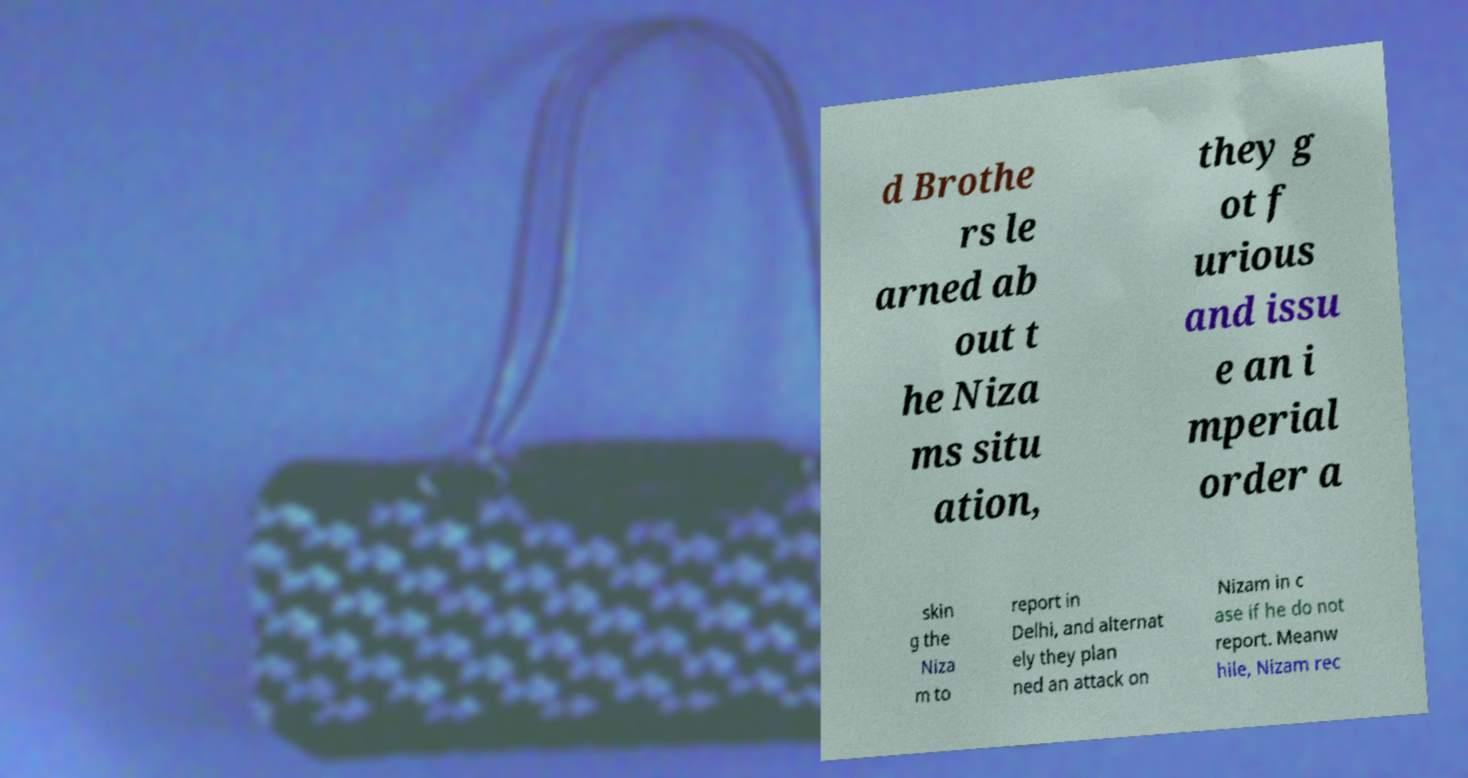Please read and relay the text visible in this image. What does it say? d Brothe rs le arned ab out t he Niza ms situ ation, they g ot f urious and issu e an i mperial order a skin g the Niza m to report in Delhi, and alternat ely they plan ned an attack on Nizam in c ase if he do not report. Meanw hile, Nizam rec 